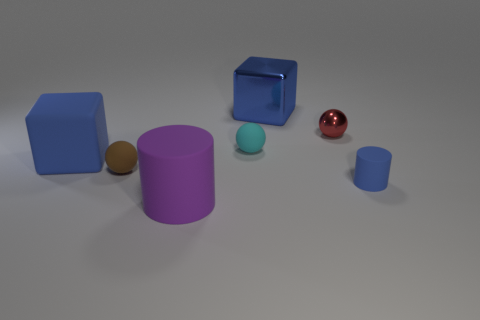Subtract 1 spheres. How many spheres are left? 2 Add 3 tiny cyan rubber spheres. How many objects exist? 10 Subtract all spheres. How many objects are left? 4 Add 5 tiny brown metal cylinders. How many tiny brown metal cylinders exist? 5 Subtract 0 red cubes. How many objects are left? 7 Subtract all tiny purple metal cylinders. Subtract all tiny metal objects. How many objects are left? 6 Add 4 big blocks. How many big blocks are left? 6 